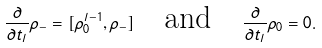<formula> <loc_0><loc_0><loc_500><loc_500>\frac { \partial } { \partial t _ { l } } \rho _ { - } = [ \rho _ { 0 } ^ { l - 1 } , \rho _ { - } ] \quad \text {and} \quad \frac { \partial } { \partial t _ { l } } \rho _ { 0 } = 0 .</formula> 